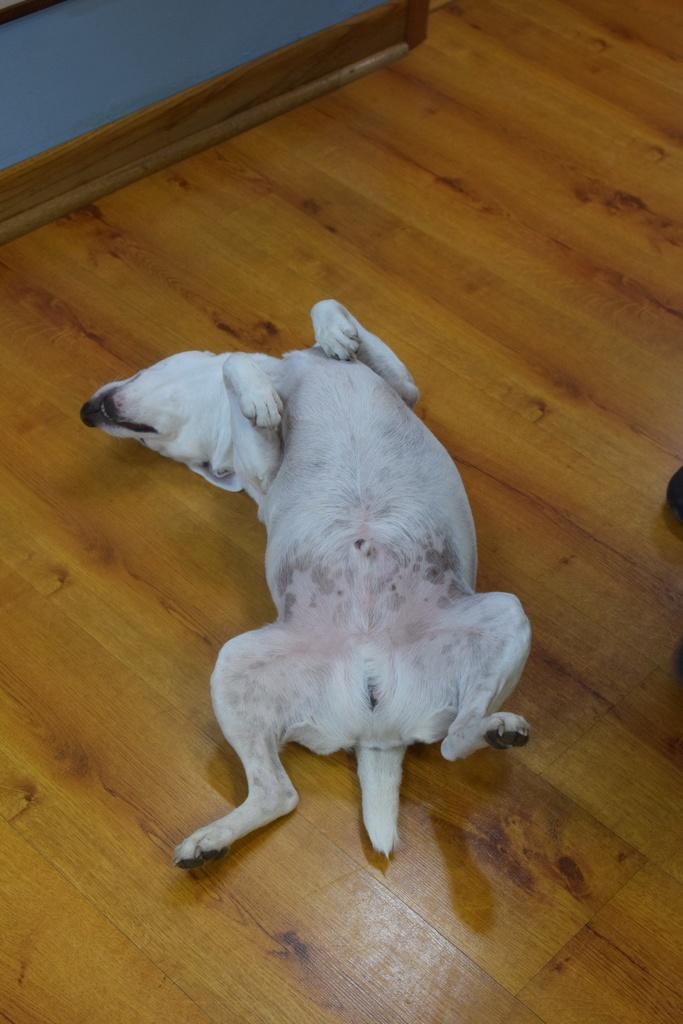What type of animal is in the image? There is a dog in the image. What is the dog doing in the image? The dog is lying on the floor. Can you describe the background of the image? There are objects in the background of the image. What type of spade is the dog using in the image? There is no spade present in the image; it features a dog lying on the floor. What religion does the dog follow in the image? The image does not provide any information about the dog's religion, as it is focused on the dog's position and the background. 